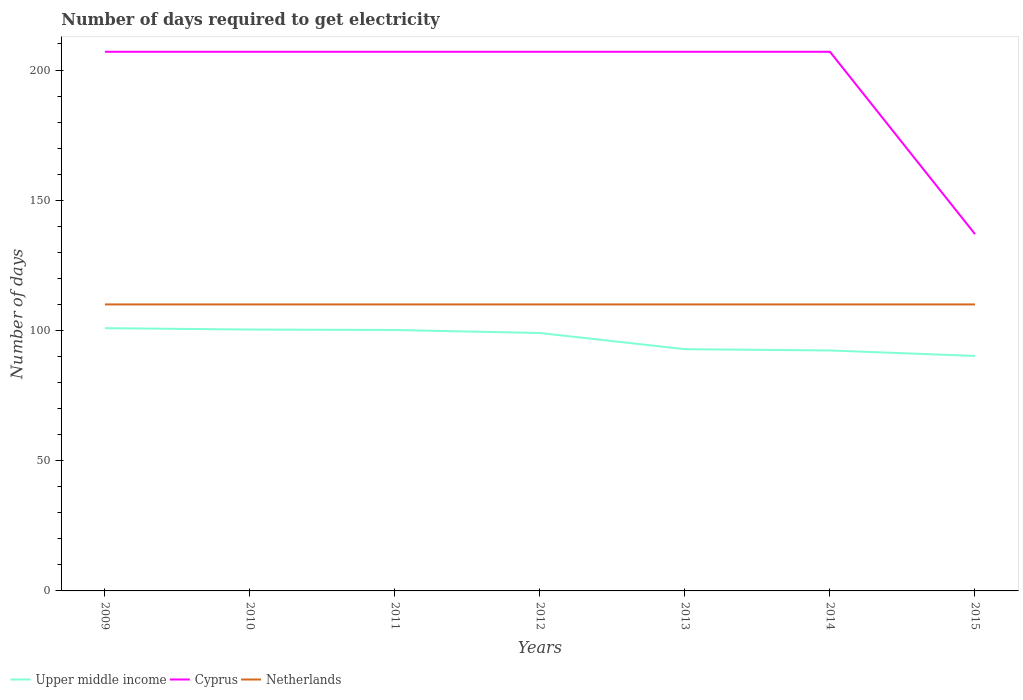How many different coloured lines are there?
Give a very brief answer. 3. Does the line corresponding to Upper middle income intersect with the line corresponding to Cyprus?
Your response must be concise. No. Is the number of lines equal to the number of legend labels?
Make the answer very short. Yes. Across all years, what is the maximum number of days required to get electricity in in Netherlands?
Keep it short and to the point. 110. In which year was the number of days required to get electricity in in Cyprus maximum?
Offer a terse response. 2015. What is the total number of days required to get electricity in in Upper middle income in the graph?
Ensure brevity in your answer.  8.08. What is the difference between the highest and the second highest number of days required to get electricity in in Cyprus?
Ensure brevity in your answer.  70. Is the number of days required to get electricity in in Netherlands strictly greater than the number of days required to get electricity in in Cyprus over the years?
Ensure brevity in your answer.  Yes. How many lines are there?
Your response must be concise. 3. Does the graph contain grids?
Keep it short and to the point. No. What is the title of the graph?
Provide a succinct answer. Number of days required to get electricity. What is the label or title of the X-axis?
Provide a succinct answer. Years. What is the label or title of the Y-axis?
Your answer should be compact. Number of days. What is the Number of days in Upper middle income in 2009?
Ensure brevity in your answer.  100.89. What is the Number of days in Cyprus in 2009?
Keep it short and to the point. 207. What is the Number of days of Netherlands in 2009?
Your answer should be very brief. 110. What is the Number of days in Upper middle income in 2010?
Your response must be concise. 100.36. What is the Number of days of Cyprus in 2010?
Give a very brief answer. 207. What is the Number of days of Netherlands in 2010?
Make the answer very short. 110. What is the Number of days of Upper middle income in 2011?
Offer a terse response. 100.18. What is the Number of days of Cyprus in 2011?
Your answer should be compact. 207. What is the Number of days in Netherlands in 2011?
Provide a short and direct response. 110. What is the Number of days in Upper middle income in 2012?
Make the answer very short. 99.02. What is the Number of days of Cyprus in 2012?
Provide a short and direct response. 207. What is the Number of days in Netherlands in 2012?
Provide a short and direct response. 110. What is the Number of days of Upper middle income in 2013?
Offer a terse response. 92.81. What is the Number of days in Cyprus in 2013?
Provide a succinct answer. 207. What is the Number of days of Netherlands in 2013?
Give a very brief answer. 110. What is the Number of days in Upper middle income in 2014?
Your answer should be compact. 92.32. What is the Number of days of Cyprus in 2014?
Keep it short and to the point. 207. What is the Number of days of Netherlands in 2014?
Your response must be concise. 110. What is the Number of days of Upper middle income in 2015?
Keep it short and to the point. 90.22. What is the Number of days of Cyprus in 2015?
Your answer should be very brief. 137. What is the Number of days in Netherlands in 2015?
Provide a short and direct response. 110. Across all years, what is the maximum Number of days in Upper middle income?
Provide a short and direct response. 100.89. Across all years, what is the maximum Number of days of Cyprus?
Offer a very short reply. 207. Across all years, what is the maximum Number of days of Netherlands?
Your answer should be very brief. 110. Across all years, what is the minimum Number of days in Upper middle income?
Your answer should be compact. 90.22. Across all years, what is the minimum Number of days of Cyprus?
Your answer should be very brief. 137. Across all years, what is the minimum Number of days of Netherlands?
Your answer should be compact. 110. What is the total Number of days in Upper middle income in the graph?
Keep it short and to the point. 675.79. What is the total Number of days in Cyprus in the graph?
Offer a very short reply. 1379. What is the total Number of days of Netherlands in the graph?
Your response must be concise. 770. What is the difference between the Number of days of Upper middle income in 2009 and that in 2010?
Ensure brevity in your answer.  0.53. What is the difference between the Number of days of Cyprus in 2009 and that in 2010?
Your response must be concise. 0. What is the difference between the Number of days in Upper middle income in 2009 and that in 2011?
Provide a short and direct response. 0.71. What is the difference between the Number of days of Netherlands in 2009 and that in 2011?
Make the answer very short. 0. What is the difference between the Number of days in Upper middle income in 2009 and that in 2012?
Provide a succinct answer. 1.87. What is the difference between the Number of days of Cyprus in 2009 and that in 2012?
Offer a very short reply. 0. What is the difference between the Number of days in Netherlands in 2009 and that in 2012?
Make the answer very short. 0. What is the difference between the Number of days of Upper middle income in 2009 and that in 2013?
Your answer should be compact. 8.08. What is the difference between the Number of days in Upper middle income in 2009 and that in 2014?
Your answer should be very brief. 8.57. What is the difference between the Number of days of Netherlands in 2009 and that in 2014?
Offer a very short reply. 0. What is the difference between the Number of days of Upper middle income in 2009 and that in 2015?
Keep it short and to the point. 10.67. What is the difference between the Number of days of Cyprus in 2009 and that in 2015?
Give a very brief answer. 70. What is the difference between the Number of days of Netherlands in 2009 and that in 2015?
Offer a very short reply. 0. What is the difference between the Number of days in Upper middle income in 2010 and that in 2011?
Provide a short and direct response. 0.18. What is the difference between the Number of days in Upper middle income in 2010 and that in 2012?
Your answer should be very brief. 1.33. What is the difference between the Number of days in Cyprus in 2010 and that in 2012?
Ensure brevity in your answer.  0. What is the difference between the Number of days in Upper middle income in 2010 and that in 2013?
Your response must be concise. 7.55. What is the difference between the Number of days of Upper middle income in 2010 and that in 2014?
Give a very brief answer. 8.04. What is the difference between the Number of days in Cyprus in 2010 and that in 2014?
Provide a short and direct response. 0. What is the difference between the Number of days in Upper middle income in 2010 and that in 2015?
Make the answer very short. 10.14. What is the difference between the Number of days of Netherlands in 2010 and that in 2015?
Provide a succinct answer. 0. What is the difference between the Number of days of Upper middle income in 2011 and that in 2012?
Your answer should be compact. 1.16. What is the difference between the Number of days in Cyprus in 2011 and that in 2012?
Offer a terse response. 0. What is the difference between the Number of days of Upper middle income in 2011 and that in 2013?
Provide a succinct answer. 7.37. What is the difference between the Number of days of Netherlands in 2011 and that in 2013?
Keep it short and to the point. 0. What is the difference between the Number of days of Upper middle income in 2011 and that in 2014?
Make the answer very short. 7.86. What is the difference between the Number of days of Upper middle income in 2011 and that in 2015?
Keep it short and to the point. 9.96. What is the difference between the Number of days of Cyprus in 2011 and that in 2015?
Your answer should be compact. 70. What is the difference between the Number of days of Netherlands in 2011 and that in 2015?
Keep it short and to the point. 0. What is the difference between the Number of days in Upper middle income in 2012 and that in 2013?
Your answer should be very brief. 6.21. What is the difference between the Number of days in Netherlands in 2012 and that in 2013?
Offer a terse response. 0. What is the difference between the Number of days in Upper middle income in 2012 and that in 2014?
Offer a terse response. 6.7. What is the difference between the Number of days in Netherlands in 2012 and that in 2014?
Give a very brief answer. 0. What is the difference between the Number of days of Upper middle income in 2012 and that in 2015?
Offer a very short reply. 8.8. What is the difference between the Number of days in Upper middle income in 2013 and that in 2014?
Provide a succinct answer. 0.49. What is the difference between the Number of days in Netherlands in 2013 and that in 2014?
Your answer should be very brief. 0. What is the difference between the Number of days of Upper middle income in 2013 and that in 2015?
Ensure brevity in your answer.  2.59. What is the difference between the Number of days in Cyprus in 2013 and that in 2015?
Your response must be concise. 70. What is the difference between the Number of days in Upper middle income in 2014 and that in 2015?
Ensure brevity in your answer.  2.1. What is the difference between the Number of days in Cyprus in 2014 and that in 2015?
Make the answer very short. 70. What is the difference between the Number of days in Upper middle income in 2009 and the Number of days in Cyprus in 2010?
Your answer should be very brief. -106.11. What is the difference between the Number of days of Upper middle income in 2009 and the Number of days of Netherlands in 2010?
Provide a short and direct response. -9.11. What is the difference between the Number of days in Cyprus in 2009 and the Number of days in Netherlands in 2010?
Ensure brevity in your answer.  97. What is the difference between the Number of days of Upper middle income in 2009 and the Number of days of Cyprus in 2011?
Offer a terse response. -106.11. What is the difference between the Number of days of Upper middle income in 2009 and the Number of days of Netherlands in 2011?
Your answer should be compact. -9.11. What is the difference between the Number of days of Cyprus in 2009 and the Number of days of Netherlands in 2011?
Offer a very short reply. 97. What is the difference between the Number of days in Upper middle income in 2009 and the Number of days in Cyprus in 2012?
Your answer should be very brief. -106.11. What is the difference between the Number of days in Upper middle income in 2009 and the Number of days in Netherlands in 2012?
Offer a very short reply. -9.11. What is the difference between the Number of days in Cyprus in 2009 and the Number of days in Netherlands in 2012?
Provide a succinct answer. 97. What is the difference between the Number of days in Upper middle income in 2009 and the Number of days in Cyprus in 2013?
Your answer should be very brief. -106.11. What is the difference between the Number of days in Upper middle income in 2009 and the Number of days in Netherlands in 2013?
Your answer should be compact. -9.11. What is the difference between the Number of days of Cyprus in 2009 and the Number of days of Netherlands in 2013?
Give a very brief answer. 97. What is the difference between the Number of days in Upper middle income in 2009 and the Number of days in Cyprus in 2014?
Provide a succinct answer. -106.11. What is the difference between the Number of days of Upper middle income in 2009 and the Number of days of Netherlands in 2014?
Your answer should be compact. -9.11. What is the difference between the Number of days of Cyprus in 2009 and the Number of days of Netherlands in 2014?
Your answer should be compact. 97. What is the difference between the Number of days in Upper middle income in 2009 and the Number of days in Cyprus in 2015?
Keep it short and to the point. -36.11. What is the difference between the Number of days in Upper middle income in 2009 and the Number of days in Netherlands in 2015?
Keep it short and to the point. -9.11. What is the difference between the Number of days of Cyprus in 2009 and the Number of days of Netherlands in 2015?
Make the answer very short. 97. What is the difference between the Number of days of Upper middle income in 2010 and the Number of days of Cyprus in 2011?
Make the answer very short. -106.64. What is the difference between the Number of days in Upper middle income in 2010 and the Number of days in Netherlands in 2011?
Give a very brief answer. -9.64. What is the difference between the Number of days of Cyprus in 2010 and the Number of days of Netherlands in 2011?
Your answer should be very brief. 97. What is the difference between the Number of days in Upper middle income in 2010 and the Number of days in Cyprus in 2012?
Give a very brief answer. -106.64. What is the difference between the Number of days in Upper middle income in 2010 and the Number of days in Netherlands in 2012?
Offer a terse response. -9.64. What is the difference between the Number of days in Cyprus in 2010 and the Number of days in Netherlands in 2012?
Ensure brevity in your answer.  97. What is the difference between the Number of days of Upper middle income in 2010 and the Number of days of Cyprus in 2013?
Your response must be concise. -106.64. What is the difference between the Number of days of Upper middle income in 2010 and the Number of days of Netherlands in 2013?
Keep it short and to the point. -9.64. What is the difference between the Number of days of Cyprus in 2010 and the Number of days of Netherlands in 2013?
Keep it short and to the point. 97. What is the difference between the Number of days of Upper middle income in 2010 and the Number of days of Cyprus in 2014?
Keep it short and to the point. -106.64. What is the difference between the Number of days of Upper middle income in 2010 and the Number of days of Netherlands in 2014?
Provide a succinct answer. -9.64. What is the difference between the Number of days in Cyprus in 2010 and the Number of days in Netherlands in 2014?
Offer a very short reply. 97. What is the difference between the Number of days of Upper middle income in 2010 and the Number of days of Cyprus in 2015?
Give a very brief answer. -36.64. What is the difference between the Number of days in Upper middle income in 2010 and the Number of days in Netherlands in 2015?
Make the answer very short. -9.64. What is the difference between the Number of days in Cyprus in 2010 and the Number of days in Netherlands in 2015?
Offer a terse response. 97. What is the difference between the Number of days in Upper middle income in 2011 and the Number of days in Cyprus in 2012?
Make the answer very short. -106.82. What is the difference between the Number of days of Upper middle income in 2011 and the Number of days of Netherlands in 2012?
Ensure brevity in your answer.  -9.82. What is the difference between the Number of days of Cyprus in 2011 and the Number of days of Netherlands in 2012?
Offer a terse response. 97. What is the difference between the Number of days of Upper middle income in 2011 and the Number of days of Cyprus in 2013?
Offer a very short reply. -106.82. What is the difference between the Number of days of Upper middle income in 2011 and the Number of days of Netherlands in 2013?
Your response must be concise. -9.82. What is the difference between the Number of days of Cyprus in 2011 and the Number of days of Netherlands in 2013?
Ensure brevity in your answer.  97. What is the difference between the Number of days of Upper middle income in 2011 and the Number of days of Cyprus in 2014?
Give a very brief answer. -106.82. What is the difference between the Number of days of Upper middle income in 2011 and the Number of days of Netherlands in 2014?
Provide a succinct answer. -9.82. What is the difference between the Number of days of Cyprus in 2011 and the Number of days of Netherlands in 2014?
Your answer should be very brief. 97. What is the difference between the Number of days in Upper middle income in 2011 and the Number of days in Cyprus in 2015?
Offer a terse response. -36.82. What is the difference between the Number of days in Upper middle income in 2011 and the Number of days in Netherlands in 2015?
Keep it short and to the point. -9.82. What is the difference between the Number of days of Cyprus in 2011 and the Number of days of Netherlands in 2015?
Your answer should be very brief. 97. What is the difference between the Number of days of Upper middle income in 2012 and the Number of days of Cyprus in 2013?
Give a very brief answer. -107.98. What is the difference between the Number of days of Upper middle income in 2012 and the Number of days of Netherlands in 2013?
Your answer should be compact. -10.98. What is the difference between the Number of days in Cyprus in 2012 and the Number of days in Netherlands in 2013?
Give a very brief answer. 97. What is the difference between the Number of days of Upper middle income in 2012 and the Number of days of Cyprus in 2014?
Offer a terse response. -107.98. What is the difference between the Number of days of Upper middle income in 2012 and the Number of days of Netherlands in 2014?
Your answer should be compact. -10.98. What is the difference between the Number of days of Cyprus in 2012 and the Number of days of Netherlands in 2014?
Your answer should be very brief. 97. What is the difference between the Number of days in Upper middle income in 2012 and the Number of days in Cyprus in 2015?
Your answer should be very brief. -37.98. What is the difference between the Number of days in Upper middle income in 2012 and the Number of days in Netherlands in 2015?
Offer a terse response. -10.98. What is the difference between the Number of days in Cyprus in 2012 and the Number of days in Netherlands in 2015?
Your answer should be compact. 97. What is the difference between the Number of days in Upper middle income in 2013 and the Number of days in Cyprus in 2014?
Ensure brevity in your answer.  -114.19. What is the difference between the Number of days in Upper middle income in 2013 and the Number of days in Netherlands in 2014?
Offer a terse response. -17.19. What is the difference between the Number of days of Cyprus in 2013 and the Number of days of Netherlands in 2014?
Ensure brevity in your answer.  97. What is the difference between the Number of days in Upper middle income in 2013 and the Number of days in Cyprus in 2015?
Give a very brief answer. -44.19. What is the difference between the Number of days of Upper middle income in 2013 and the Number of days of Netherlands in 2015?
Keep it short and to the point. -17.19. What is the difference between the Number of days of Cyprus in 2013 and the Number of days of Netherlands in 2015?
Provide a short and direct response. 97. What is the difference between the Number of days of Upper middle income in 2014 and the Number of days of Cyprus in 2015?
Provide a succinct answer. -44.68. What is the difference between the Number of days of Upper middle income in 2014 and the Number of days of Netherlands in 2015?
Offer a very short reply. -17.68. What is the difference between the Number of days in Cyprus in 2014 and the Number of days in Netherlands in 2015?
Your response must be concise. 97. What is the average Number of days of Upper middle income per year?
Offer a very short reply. 96.54. What is the average Number of days in Cyprus per year?
Provide a short and direct response. 197. What is the average Number of days in Netherlands per year?
Keep it short and to the point. 110. In the year 2009, what is the difference between the Number of days of Upper middle income and Number of days of Cyprus?
Give a very brief answer. -106.11. In the year 2009, what is the difference between the Number of days in Upper middle income and Number of days in Netherlands?
Give a very brief answer. -9.11. In the year 2009, what is the difference between the Number of days of Cyprus and Number of days of Netherlands?
Keep it short and to the point. 97. In the year 2010, what is the difference between the Number of days in Upper middle income and Number of days in Cyprus?
Ensure brevity in your answer.  -106.64. In the year 2010, what is the difference between the Number of days of Upper middle income and Number of days of Netherlands?
Keep it short and to the point. -9.64. In the year 2010, what is the difference between the Number of days in Cyprus and Number of days in Netherlands?
Your answer should be compact. 97. In the year 2011, what is the difference between the Number of days in Upper middle income and Number of days in Cyprus?
Your response must be concise. -106.82. In the year 2011, what is the difference between the Number of days in Upper middle income and Number of days in Netherlands?
Your answer should be compact. -9.82. In the year 2011, what is the difference between the Number of days in Cyprus and Number of days in Netherlands?
Offer a terse response. 97. In the year 2012, what is the difference between the Number of days in Upper middle income and Number of days in Cyprus?
Provide a short and direct response. -107.98. In the year 2012, what is the difference between the Number of days of Upper middle income and Number of days of Netherlands?
Your answer should be very brief. -10.98. In the year 2012, what is the difference between the Number of days in Cyprus and Number of days in Netherlands?
Keep it short and to the point. 97. In the year 2013, what is the difference between the Number of days of Upper middle income and Number of days of Cyprus?
Your answer should be very brief. -114.19. In the year 2013, what is the difference between the Number of days of Upper middle income and Number of days of Netherlands?
Provide a short and direct response. -17.19. In the year 2013, what is the difference between the Number of days of Cyprus and Number of days of Netherlands?
Offer a very short reply. 97. In the year 2014, what is the difference between the Number of days of Upper middle income and Number of days of Cyprus?
Your answer should be very brief. -114.68. In the year 2014, what is the difference between the Number of days of Upper middle income and Number of days of Netherlands?
Make the answer very short. -17.68. In the year 2014, what is the difference between the Number of days in Cyprus and Number of days in Netherlands?
Give a very brief answer. 97. In the year 2015, what is the difference between the Number of days in Upper middle income and Number of days in Cyprus?
Provide a short and direct response. -46.78. In the year 2015, what is the difference between the Number of days in Upper middle income and Number of days in Netherlands?
Make the answer very short. -19.78. What is the ratio of the Number of days of Cyprus in 2009 to that in 2010?
Provide a short and direct response. 1. What is the ratio of the Number of days in Upper middle income in 2009 to that in 2011?
Provide a short and direct response. 1.01. What is the ratio of the Number of days of Cyprus in 2009 to that in 2011?
Offer a terse response. 1. What is the ratio of the Number of days of Upper middle income in 2009 to that in 2012?
Give a very brief answer. 1.02. What is the ratio of the Number of days in Cyprus in 2009 to that in 2012?
Make the answer very short. 1. What is the ratio of the Number of days in Upper middle income in 2009 to that in 2013?
Provide a succinct answer. 1.09. What is the ratio of the Number of days of Cyprus in 2009 to that in 2013?
Ensure brevity in your answer.  1. What is the ratio of the Number of days of Upper middle income in 2009 to that in 2014?
Provide a succinct answer. 1.09. What is the ratio of the Number of days in Cyprus in 2009 to that in 2014?
Make the answer very short. 1. What is the ratio of the Number of days of Upper middle income in 2009 to that in 2015?
Give a very brief answer. 1.12. What is the ratio of the Number of days in Cyprus in 2009 to that in 2015?
Offer a terse response. 1.51. What is the ratio of the Number of days of Cyprus in 2010 to that in 2011?
Your answer should be compact. 1. What is the ratio of the Number of days of Netherlands in 2010 to that in 2011?
Your response must be concise. 1. What is the ratio of the Number of days of Upper middle income in 2010 to that in 2012?
Your response must be concise. 1.01. What is the ratio of the Number of days in Upper middle income in 2010 to that in 2013?
Your response must be concise. 1.08. What is the ratio of the Number of days of Upper middle income in 2010 to that in 2014?
Your answer should be very brief. 1.09. What is the ratio of the Number of days of Upper middle income in 2010 to that in 2015?
Your response must be concise. 1.11. What is the ratio of the Number of days of Cyprus in 2010 to that in 2015?
Your response must be concise. 1.51. What is the ratio of the Number of days in Netherlands in 2010 to that in 2015?
Your answer should be very brief. 1. What is the ratio of the Number of days of Upper middle income in 2011 to that in 2012?
Offer a terse response. 1.01. What is the ratio of the Number of days in Cyprus in 2011 to that in 2012?
Give a very brief answer. 1. What is the ratio of the Number of days of Netherlands in 2011 to that in 2012?
Your response must be concise. 1. What is the ratio of the Number of days of Upper middle income in 2011 to that in 2013?
Make the answer very short. 1.08. What is the ratio of the Number of days of Upper middle income in 2011 to that in 2014?
Ensure brevity in your answer.  1.09. What is the ratio of the Number of days in Upper middle income in 2011 to that in 2015?
Your answer should be compact. 1.11. What is the ratio of the Number of days of Cyprus in 2011 to that in 2015?
Provide a succinct answer. 1.51. What is the ratio of the Number of days in Upper middle income in 2012 to that in 2013?
Keep it short and to the point. 1.07. What is the ratio of the Number of days in Upper middle income in 2012 to that in 2014?
Your response must be concise. 1.07. What is the ratio of the Number of days in Netherlands in 2012 to that in 2014?
Your answer should be compact. 1. What is the ratio of the Number of days in Upper middle income in 2012 to that in 2015?
Provide a short and direct response. 1.1. What is the ratio of the Number of days in Cyprus in 2012 to that in 2015?
Give a very brief answer. 1.51. What is the ratio of the Number of days in Upper middle income in 2013 to that in 2014?
Your response must be concise. 1.01. What is the ratio of the Number of days of Upper middle income in 2013 to that in 2015?
Give a very brief answer. 1.03. What is the ratio of the Number of days in Cyprus in 2013 to that in 2015?
Offer a very short reply. 1.51. What is the ratio of the Number of days in Upper middle income in 2014 to that in 2015?
Your answer should be compact. 1.02. What is the ratio of the Number of days of Cyprus in 2014 to that in 2015?
Keep it short and to the point. 1.51. What is the difference between the highest and the second highest Number of days in Upper middle income?
Make the answer very short. 0.53. What is the difference between the highest and the second highest Number of days in Cyprus?
Provide a short and direct response. 0. What is the difference between the highest and the second highest Number of days in Netherlands?
Provide a short and direct response. 0. What is the difference between the highest and the lowest Number of days of Upper middle income?
Offer a very short reply. 10.67. 